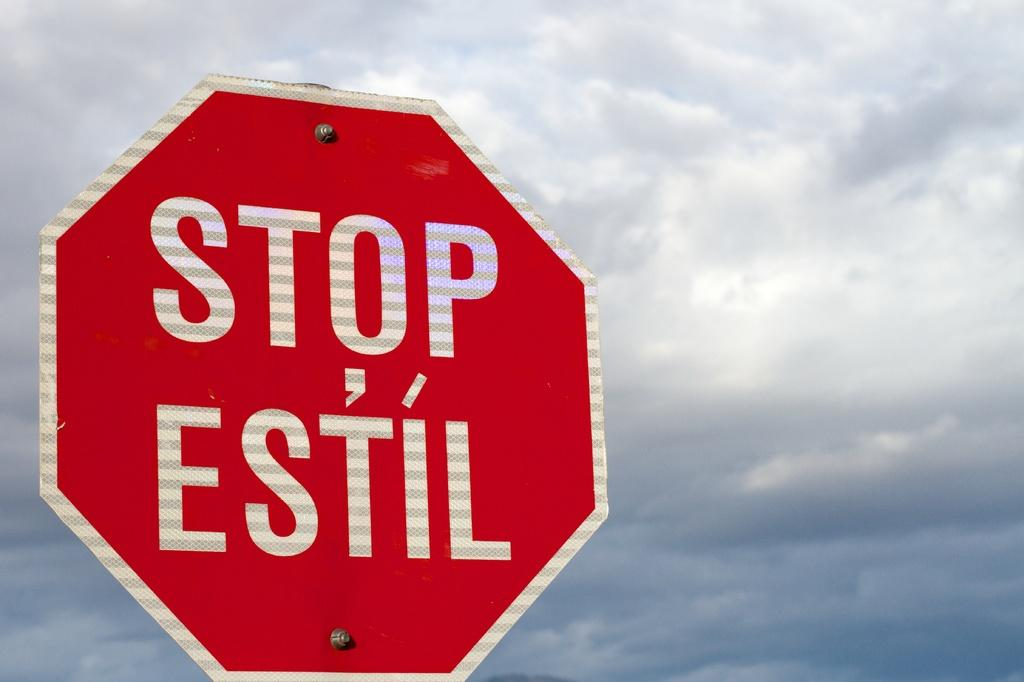<image>
Summarize the visual content of the image. Stop sign that is wrote in english and estil for spanish 